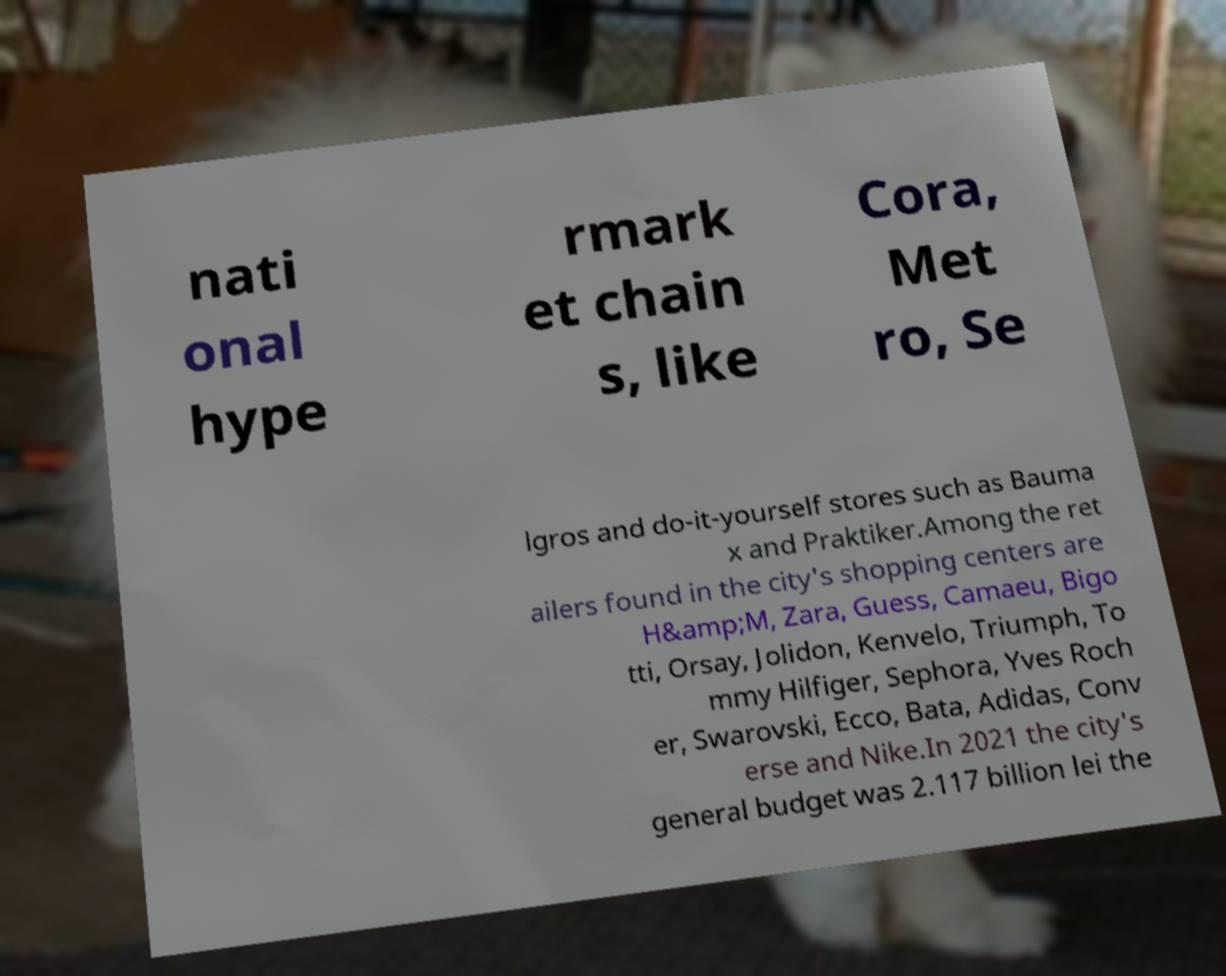Could you assist in decoding the text presented in this image and type it out clearly? nati onal hype rmark et chain s, like Cora, Met ro, Se lgros and do-it-yourself stores such as Bauma x and Praktiker.Among the ret ailers found in the city's shopping centers are H&amp;M, Zara, Guess, Camaeu, Bigo tti, Orsay, Jolidon, Kenvelo, Triumph, To mmy Hilfiger, Sephora, Yves Roch er, Swarovski, Ecco, Bata, Adidas, Conv erse and Nike.In 2021 the city's general budget was 2.117 billion lei the 